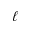<formula> <loc_0><loc_0><loc_500><loc_500>\ell</formula> 